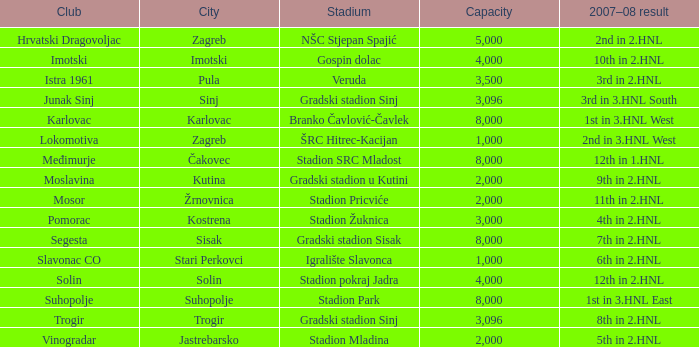What stadium has kutina as the city? Gradski stadion u Kutini. 